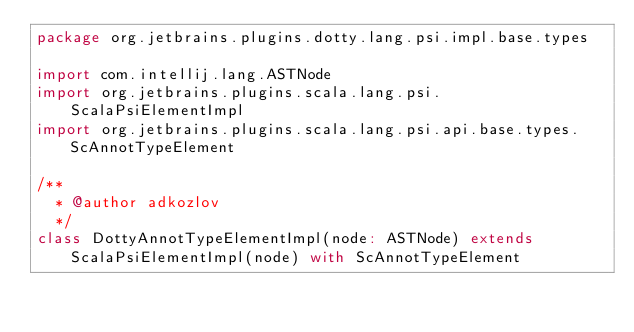<code> <loc_0><loc_0><loc_500><loc_500><_Scala_>package org.jetbrains.plugins.dotty.lang.psi.impl.base.types

import com.intellij.lang.ASTNode
import org.jetbrains.plugins.scala.lang.psi.ScalaPsiElementImpl
import org.jetbrains.plugins.scala.lang.psi.api.base.types.ScAnnotTypeElement

/**
  * @author adkozlov
  */
class DottyAnnotTypeElementImpl(node: ASTNode) extends ScalaPsiElementImpl(node) with ScAnnotTypeElement
</code> 